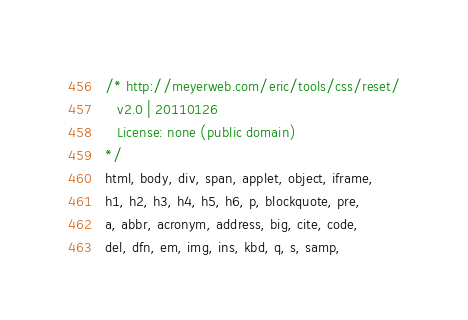Convert code to text. <code><loc_0><loc_0><loc_500><loc_500><_CSS_>/* http://meyerweb.com/eric/tools/css/reset/
   v2.0 | 20110126
   License: none (public domain)
*/
html, body, div, span, applet, object, iframe,
h1, h2, h3, h4, h5, h6, p, blockquote, pre,
a, abbr, acronym, address, big, cite, code,
del, dfn, em, img, ins, kbd, q, s, samp,</code> 